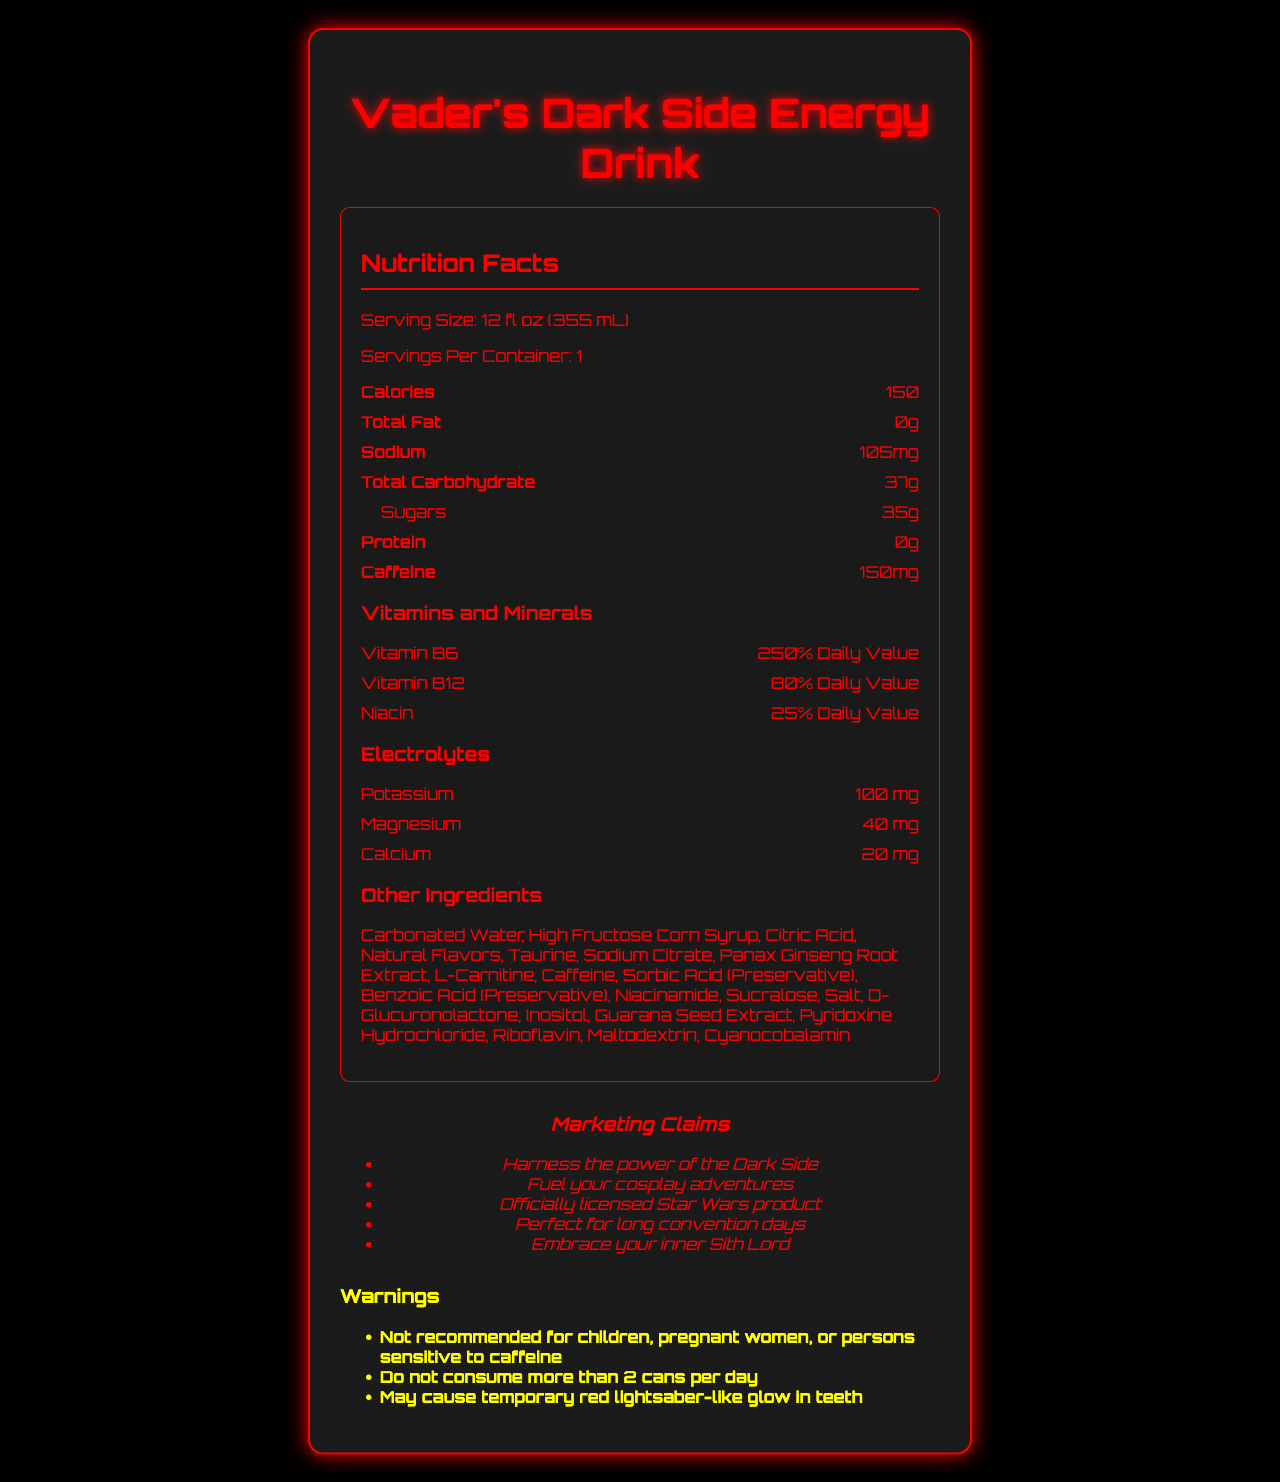What is the caffeine content in Vader's Dark Side Energy Drink? The section labeled "Caffeine" states the caffeine content as 150 mg.
Answer: 150 mg How much potassium is in the drink? The section labeled "Electrolytes" lists potassium as one of the electrolytes with a content of 100 mg.
Answer: 100 mg How many calories are in one serving of the drink? The calories are stated as 150 in the "Nutrition Facts" section.
Answer: 150 What is the serving size of Vader's Dark Side Energy Drink? The serving size is listed in the "Nutrition Facts" section as 12 fl oz (355 mL).
Answer: 12 fl oz (355 mL) What percentage of the daily value of Vitamin B6 does this drink provide? The "Vitamins and Minerals" section indicates that the drink provides 250% of the daily value for Vitamin B6.
Answer: 250% Which of the following is NOT a marketing claim made by Vader's Dark Side Energy Drink? A. Harness the power of the Dark Side B. Perfect for long convention days C. Zero calories D. Embrace your inner Sith Lord The marketing claims listed include "Harness the power of the Dark Side," "Perfect for long convention days," and "Embrace your inner Sith Lord," but do not mention "Zero calories."
Answer: C. Zero calories How many total carbohydrates are in the drink? The "Total Carbohydrate" section under "Nutrition Facts" lists carbohydrates as 37g.
Answer: 37g Is this product recommended for children according to the warnings? The warnings section specifically states that the product is not recommended for children.
Answer: No How many servings are there per container? The "Nutrition Facts" section states that there is 1 serving per container.
Answer: 1 What is the main idea of the document? The document aims to inform consumers about the ingredients, nutritional values, suggested consumption amounts, and specific warnings related to Vader's Dark Side Energy Drink.
Answer: The document provides detailed nutritional information for Vader's Dark Side Energy Drink, emphasizing its high caffeine content, electrolyte presence, marketing claims, and warnings. How much sodium is in Vader's Dark Side Energy Drink? The sodium content is listed as 105 mg in the "Nutrition Facts" section.
Answer: 105 mg Which electrolyte is present in the smallest amount? A. Potassium B. Magnesium C. Calcium D. All are equal The "Electrolytes" section lists calcium as 20 mg, which is less than potassium (100 mg) and magnesium (40 mg).
Answer: C. Calcium Based on the listed ingredients, does the drink contain any preservatives? The ingredients list includes "Sorbic Acid" and "Benzoic Acid," both of which are preservatives.
Answer: Yes What electrolyte content might be most relevant to someone who needs to replenish their body's potassium levels quickly? The "Electrolytes" section lists potassium as 100 mg, the highest among the electrolytes listed.
Answer: Potassium 100 mg What are the warnings given about consuming this drink? The warnings section provides these three specific warnings.
Answer: Not recommended for children, pregnant women, or persons sensitive to caffeine; Do not consume more than 2 cans per day; May cause temporary red lightsaber-like glow in teeth Does the document specify how much protein is in the drink? The "Nutrition Facts" section lists protein content as 0g.
Answer: 0g Can we determine the amount of taurine in the drink from the document? The document lists taurine as an ingredient but does not specify the quantity.
Answer: Cannot be determined 